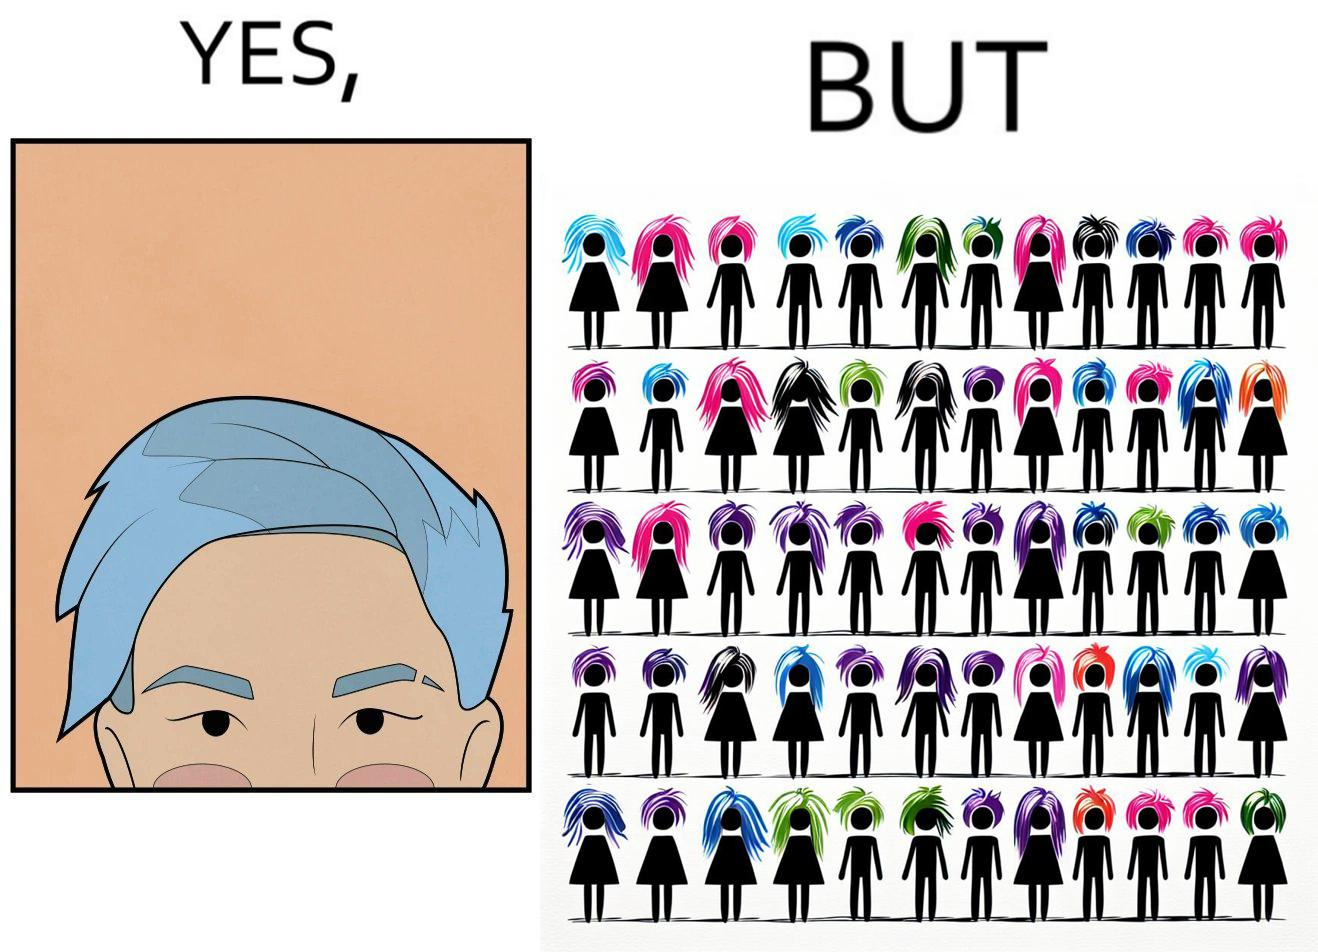What is shown in the left half versus the right half of this image? In the left part of the image: a person with hair dyed blue. In the right part of the image: a group of people having hair dyed in different colors. 